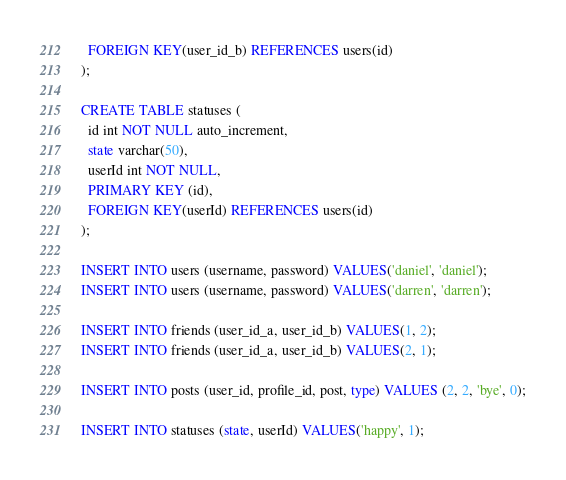<code> <loc_0><loc_0><loc_500><loc_500><_SQL_>  FOREIGN KEY(user_id_b) REFERENCES users(id)
);

CREATE TABLE statuses (
  id int NOT NULL auto_increment,
  state varchar(50),
  userId int NOT NULL,
  PRIMARY KEY (id),
  FOREIGN KEY(userId) REFERENCES users(id) 
);

INSERT INTO users (username, password) VALUES('daniel', 'daniel');
INSERT INTO users (username, password) VALUES('darren', 'darren');

INSERT INTO friends (user_id_a, user_id_b) VALUES(1, 2);
INSERT INTO friends (user_id_a, user_id_b) VALUES(2, 1);

INSERT INTO posts (user_id, profile_id, post, type) VALUES (2, 2, 'bye', 0);

INSERT INTO statuses (state, userId) VALUES('happy', 1);

</code> 